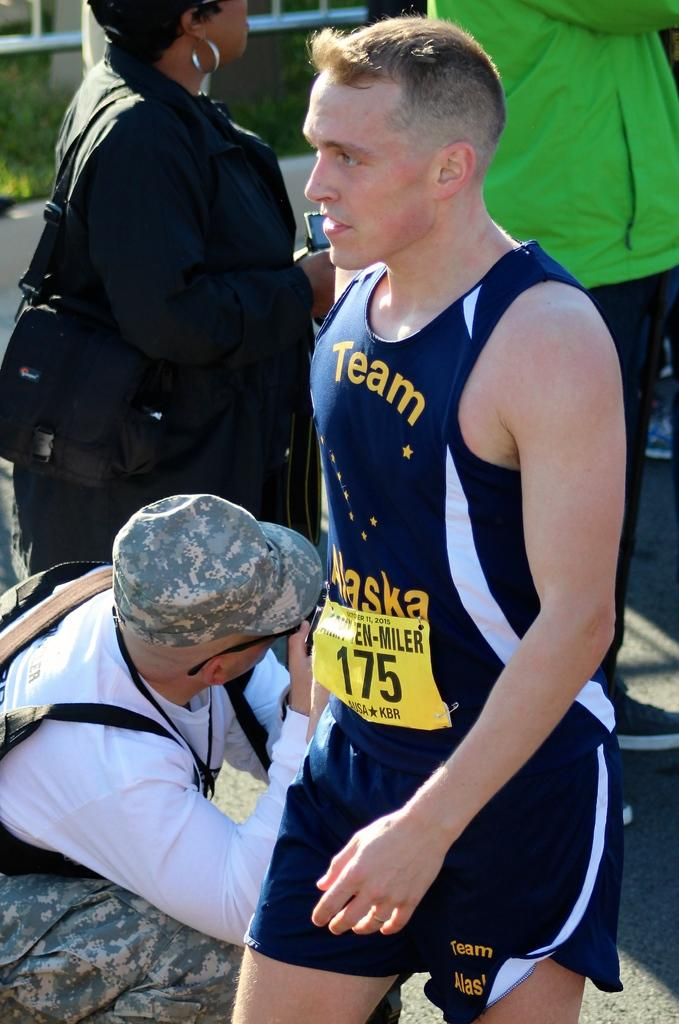<image>
Share a concise interpretation of the image provided. A male runner #175 is shown from the side in his blue and yellow uniform from Team Alaska. 